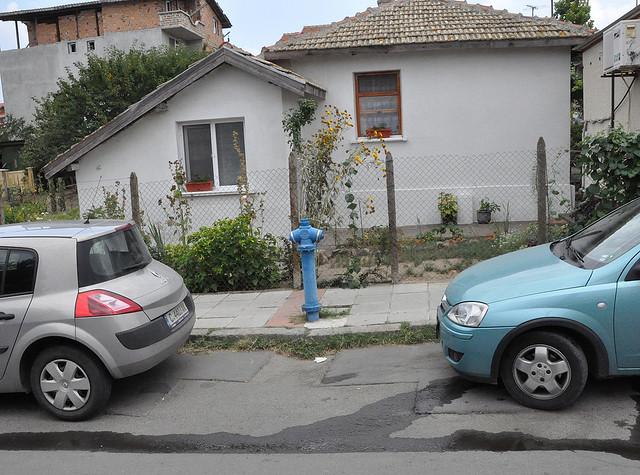What has happened to the paint on the building?
Answer briefly. Nothing. How many square feet does this house have?
Write a very short answer. 1000. What are the number on the house?
Write a very short answer. 0. Are there people in the scene?
Answer briefly. No. What color are the flowers behind the fire hydrant?
Keep it brief. Yellow. What color is the car closest to the left?
Be succinct. Gray. What is the gray and red thing used for?
Be succinct. Driving. Is there a place to pay for parking a car?
Give a very brief answer. No. What color is the car?
Short answer required. Gray. Is the house old?
Be succinct. Yes. What is the purpose of the device on the curb?
Give a very brief answer. Provide water to put out fires. How many stories is the brown house?
Quick response, please. 2. 